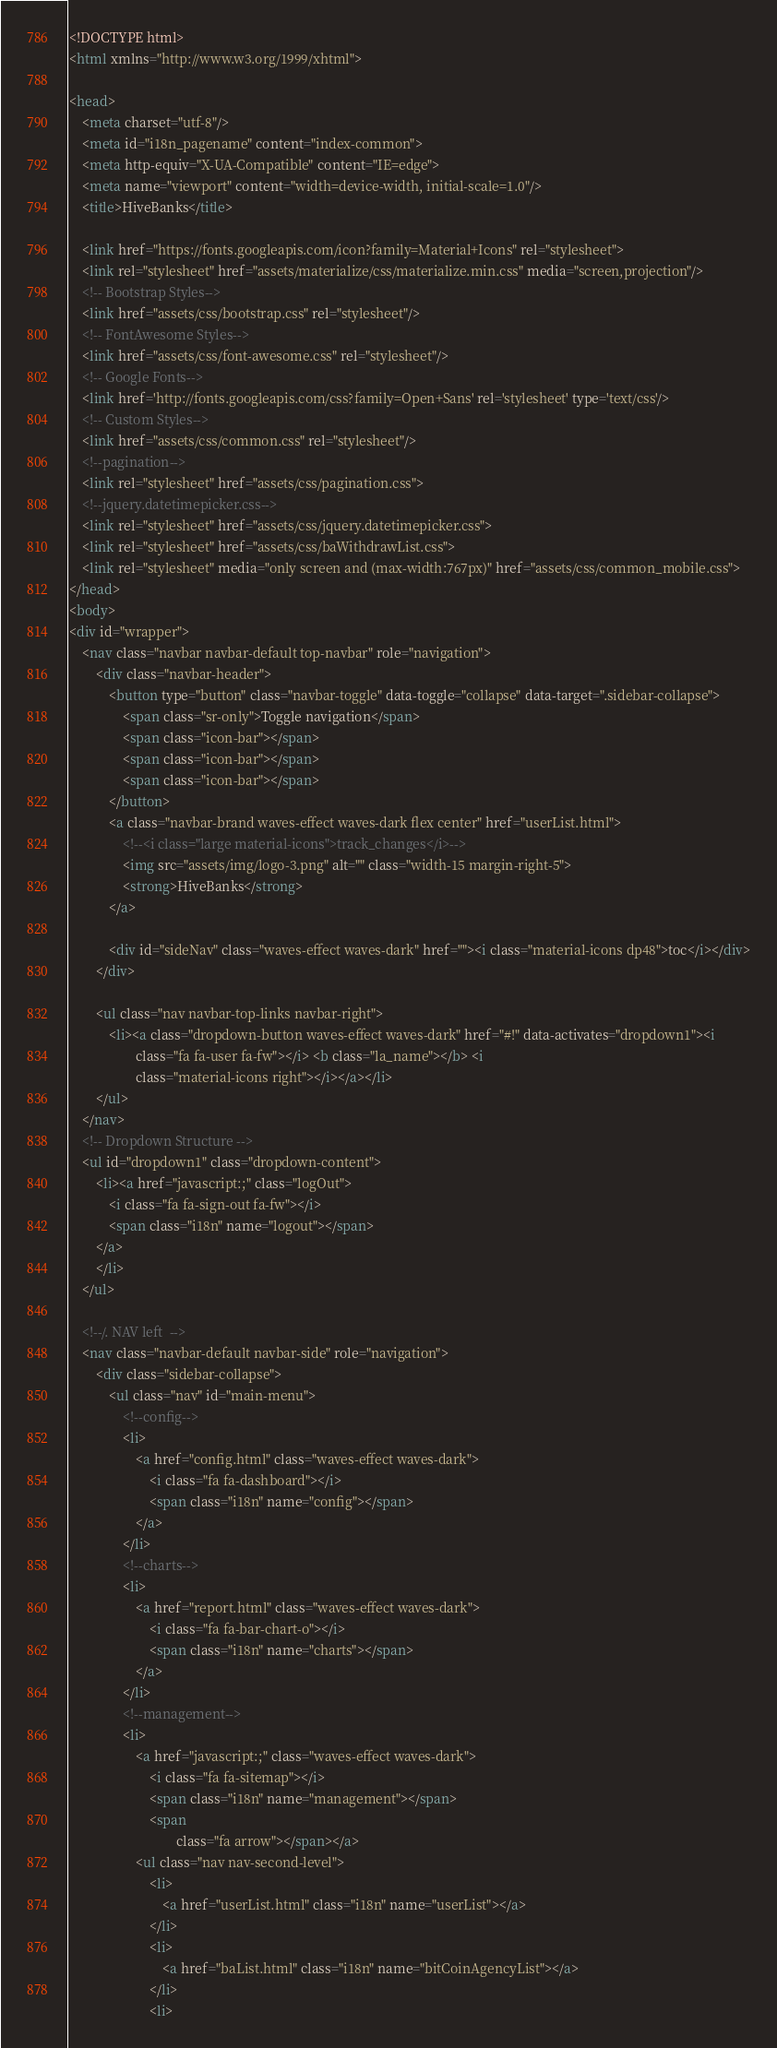Convert code to text. <code><loc_0><loc_0><loc_500><loc_500><_HTML_><!DOCTYPE html>
<html xmlns="http://www.w3.org/1999/xhtml">

<head>
    <meta charset="utf-8"/>
    <meta id="i18n_pagename" content="index-common">
    <meta http-equiv="X-UA-Compatible" content="IE=edge">
    <meta name="viewport" content="width=device-width, initial-scale=1.0"/>
    <title>HiveBanks</title>

    <link href="https://fonts.googleapis.com/icon?family=Material+Icons" rel="stylesheet">
    <link rel="stylesheet" href="assets/materialize/css/materialize.min.css" media="screen,projection"/>
    <!-- Bootstrap Styles-->
    <link href="assets/css/bootstrap.css" rel="stylesheet"/>
    <!-- FontAwesome Styles-->
    <link href="assets/css/font-awesome.css" rel="stylesheet"/>
    <!-- Google Fonts-->
    <link href='http://fonts.googleapis.com/css?family=Open+Sans' rel='stylesheet' type='text/css'/>
    <!-- Custom Styles-->
    <link href="assets/css/common.css" rel="stylesheet"/>
    <!--pagination-->
    <link rel="stylesheet" href="assets/css/pagination.css">
    <!--jquery.datetimepicker.css-->
    <link rel="stylesheet" href="assets/css/jquery.datetimepicker.css">
    <link rel="stylesheet" href="assets/css/baWithdrawList.css">
    <link rel="stylesheet" media="only screen and (max-width:767px)" href="assets/css/common_mobile.css">
</head>
<body>
<div id="wrapper">
    <nav class="navbar navbar-default top-navbar" role="navigation">
        <div class="navbar-header">
            <button type="button" class="navbar-toggle" data-toggle="collapse" data-target=".sidebar-collapse">
                <span class="sr-only">Toggle navigation</span>
                <span class="icon-bar"></span>
                <span class="icon-bar"></span>
                <span class="icon-bar"></span>
            </button>
            <a class="navbar-brand waves-effect waves-dark flex center" href="userList.html">
                <!--<i class="large material-icons">track_changes</i>-->
                <img src="assets/img/logo-3.png" alt="" class="width-15 margin-right-5">
                <strong>HiveBanks</strong>
            </a>

            <div id="sideNav" class="waves-effect waves-dark" href=""><i class="material-icons dp48">toc</i></div>
        </div>

        <ul class="nav navbar-top-links navbar-right">
            <li><a class="dropdown-button waves-effect waves-dark" href="#!" data-activates="dropdown1"><i
                    class="fa fa-user fa-fw"></i> <b class="la_name"></b> <i
                    class="material-icons right"></i></a></li>
        </ul>
    </nav>
    <!-- Dropdown Structure -->
    <ul id="dropdown1" class="dropdown-content">
        <li><a href="javascript:;" class="logOut">
            <i class="fa fa-sign-out fa-fw"></i>
            <span class="i18n" name="logout"></span>
        </a>
        </li>
    </ul>

    <!--/. NAV left  -->
    <nav class="navbar-default navbar-side" role="navigation">
        <div class="sidebar-collapse">
            <ul class="nav" id="main-menu">
                <!--config-->
                <li>
                    <a href="config.html" class="waves-effect waves-dark">
                        <i class="fa fa-dashboard"></i>
                        <span class="i18n" name="config"></span>
                    </a>
                </li>
                <!--charts-->
                <li>
                    <a href="report.html" class="waves-effect waves-dark">
                        <i class="fa fa-bar-chart-o"></i>
                        <span class="i18n" name="charts"></span>
                    </a>
                </li>
                <!--management-->
                <li>
                    <a href="javascript:;" class="waves-effect waves-dark">
                        <i class="fa fa-sitemap"></i>
                        <span class="i18n" name="management"></span>
                        <span
                                class="fa arrow"></span></a>
                    <ul class="nav nav-second-level">
                        <li>
                            <a href="userList.html" class="i18n" name="userList"></a>
                        </li>
                        <li>
                            <a href="baList.html" class="i18n" name="bitCoinAgencyList"></a>
                        </li>
                        <li></code> 